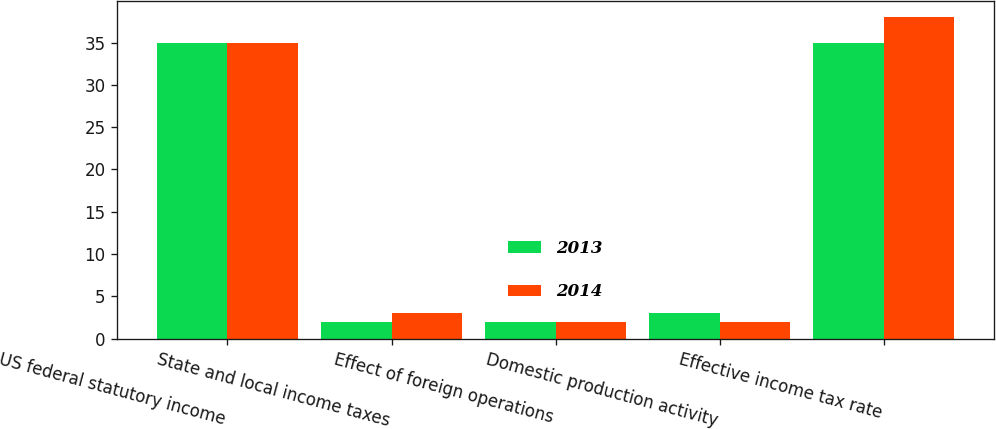Convert chart. <chart><loc_0><loc_0><loc_500><loc_500><stacked_bar_chart><ecel><fcel>US federal statutory income<fcel>State and local income taxes<fcel>Effect of foreign operations<fcel>Domestic production activity<fcel>Effective income tax rate<nl><fcel>2013<fcel>35<fcel>2<fcel>2<fcel>3<fcel>35<nl><fcel>2014<fcel>35<fcel>3<fcel>2<fcel>2<fcel>38<nl></chart> 